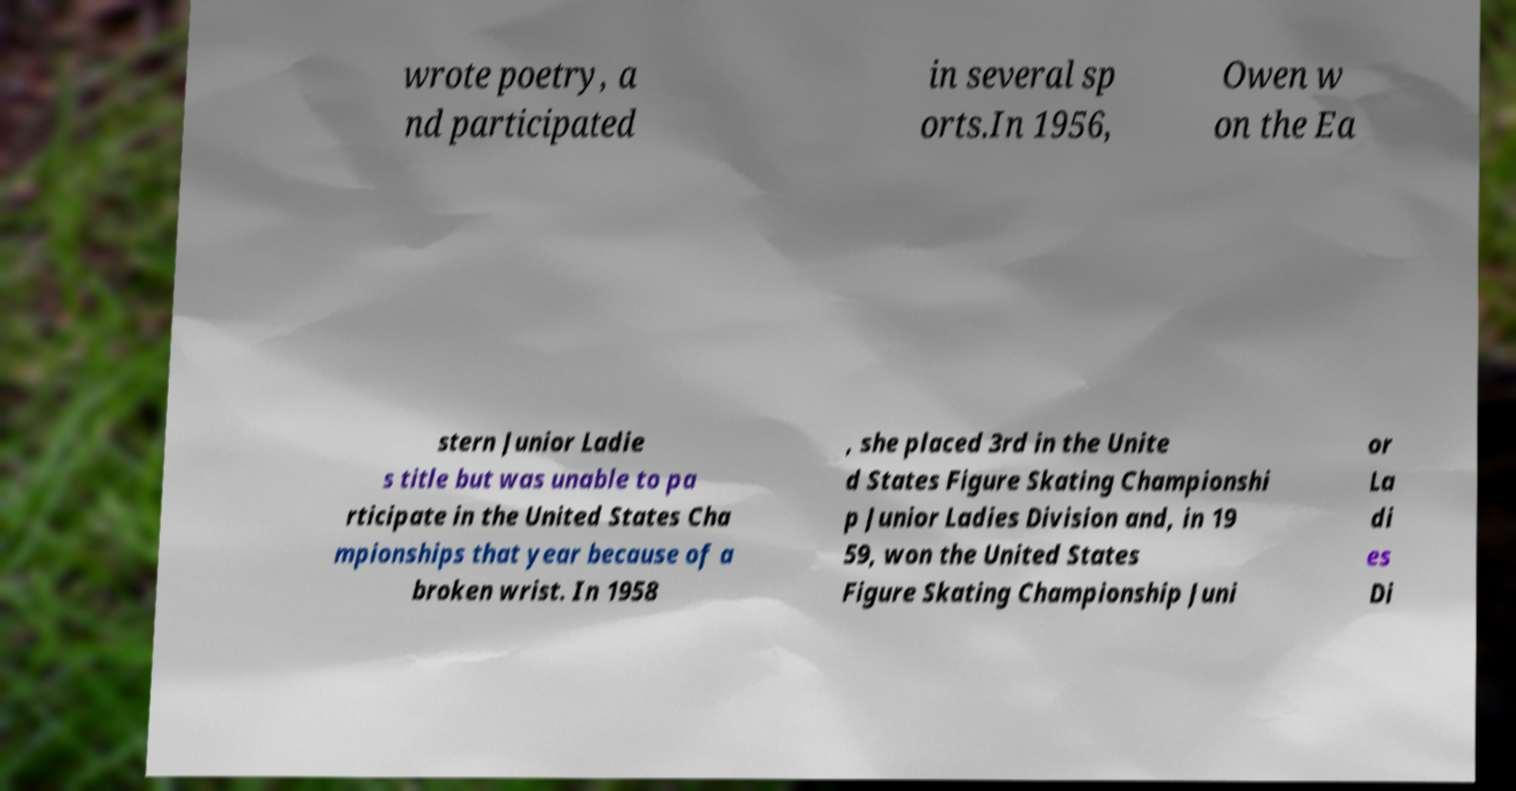What messages or text are displayed in this image? I need them in a readable, typed format. wrote poetry, a nd participated in several sp orts.In 1956, Owen w on the Ea stern Junior Ladie s title but was unable to pa rticipate in the United States Cha mpionships that year because of a broken wrist. In 1958 , she placed 3rd in the Unite d States Figure Skating Championshi p Junior Ladies Division and, in 19 59, won the United States Figure Skating Championship Juni or La di es Di 